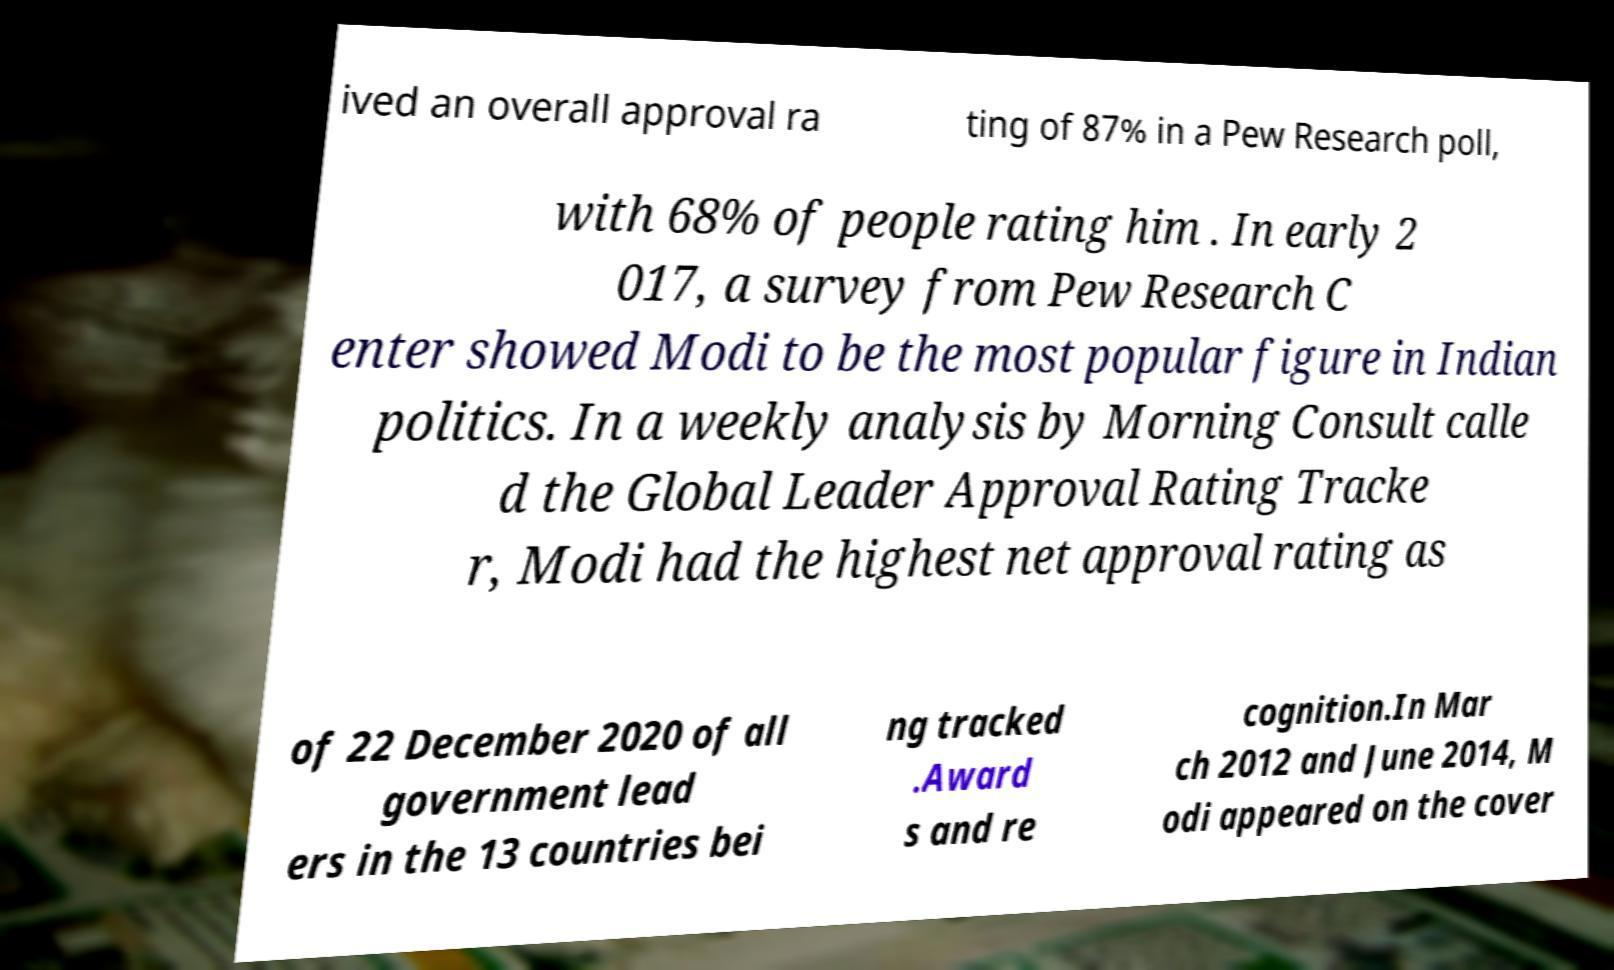I need the written content from this picture converted into text. Can you do that? ived an overall approval ra ting of 87% in a Pew Research poll, with 68% of people rating him . In early 2 017, a survey from Pew Research C enter showed Modi to be the most popular figure in Indian politics. In a weekly analysis by Morning Consult calle d the Global Leader Approval Rating Tracke r, Modi had the highest net approval rating as of 22 December 2020 of all government lead ers in the 13 countries bei ng tracked .Award s and re cognition.In Mar ch 2012 and June 2014, M odi appeared on the cover 